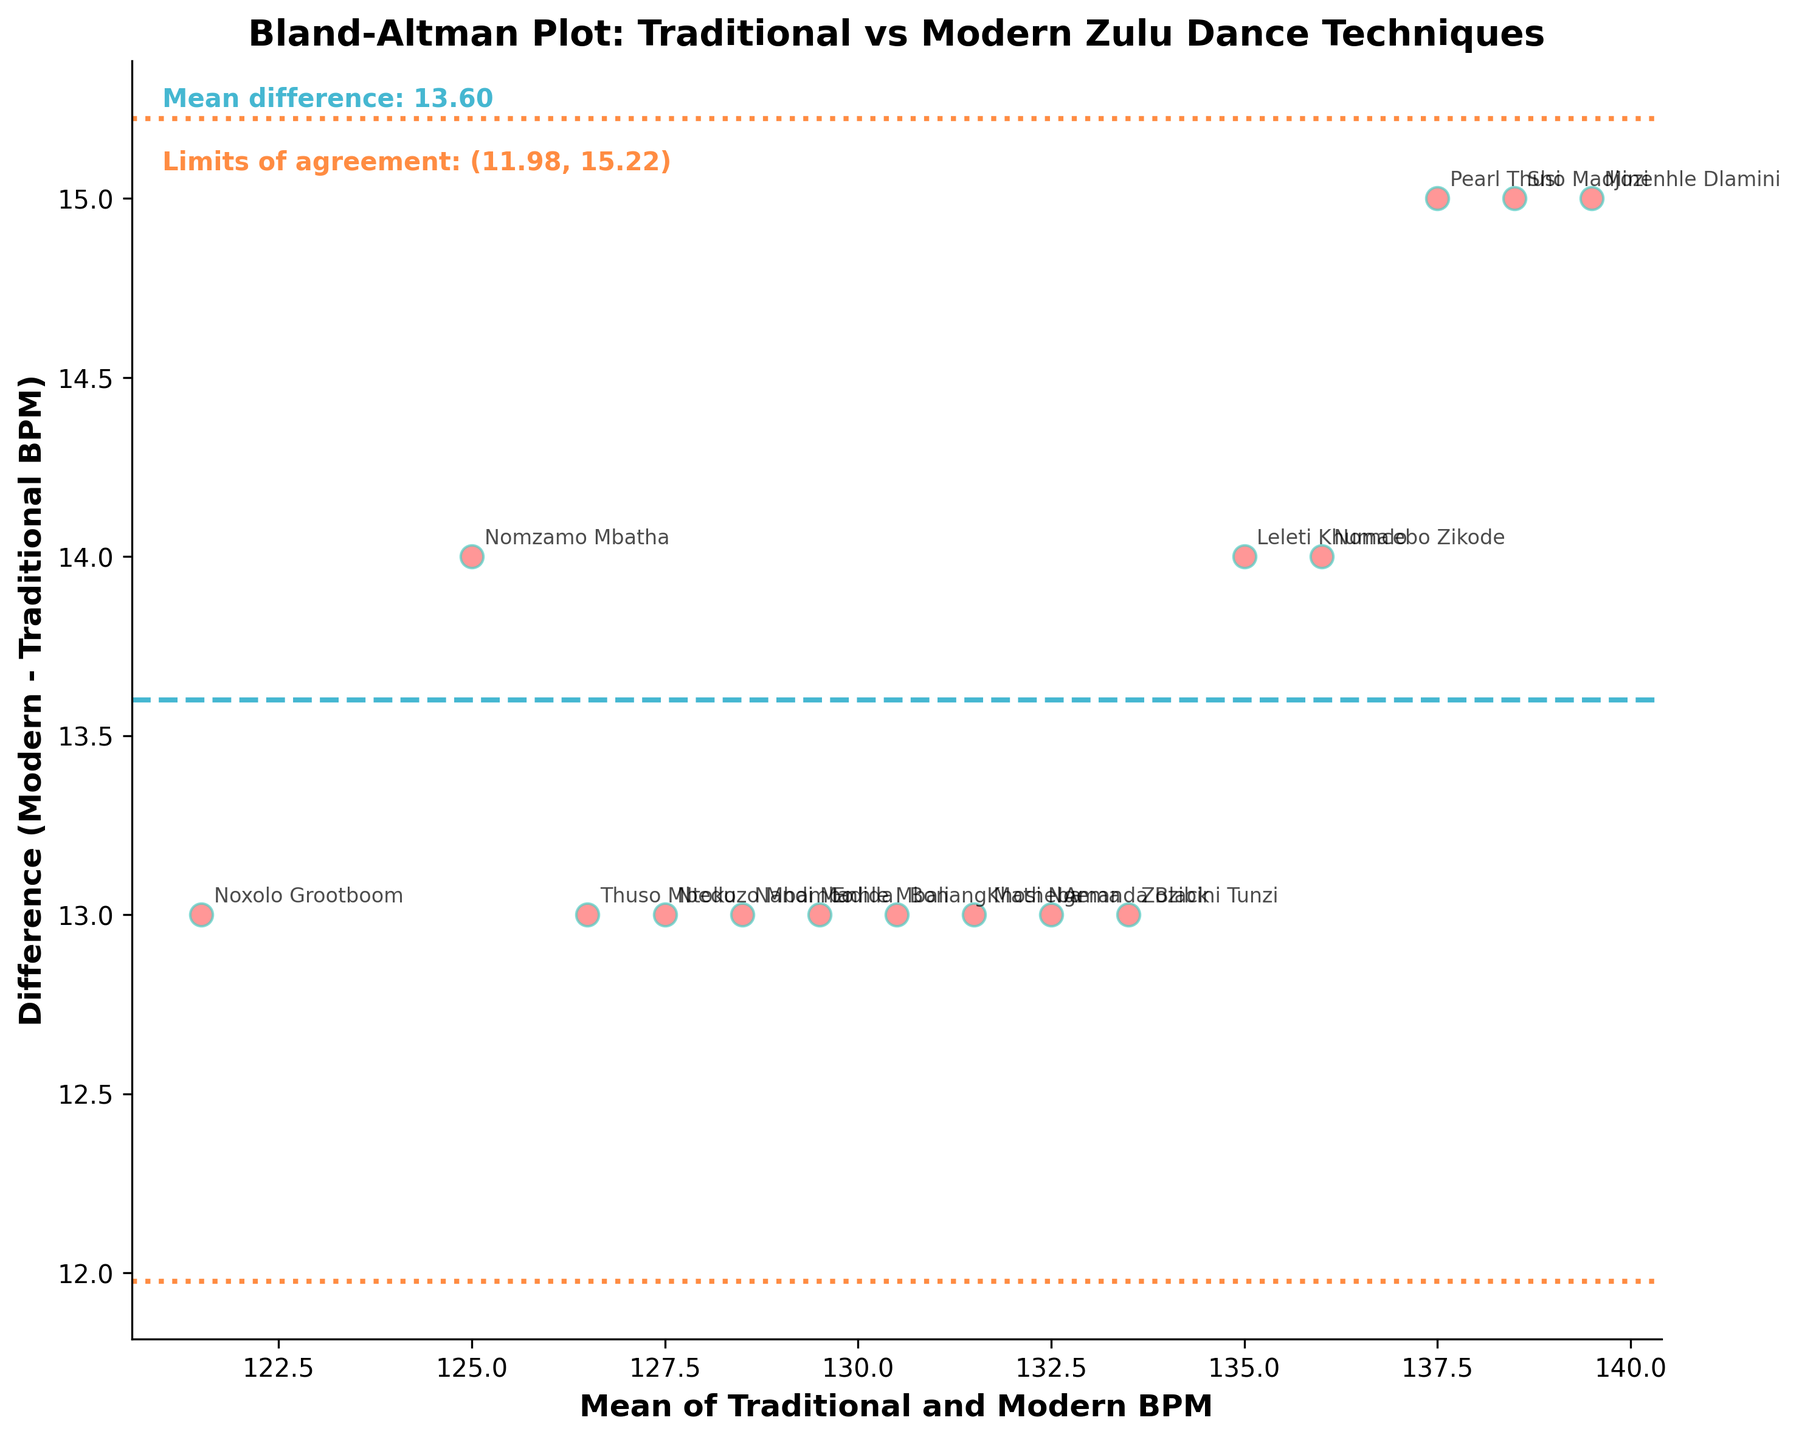What is the title of the plot? The title is typically found at the top of the plot and provides a summary of what the plot represents. In this case, it mentions the comparison between traditional and modern Zulu dance techniques.
Answer: Bland-Altman Plot: Traditional vs Modern Zulu Dance Techniques How many performers' data points are shown in the plot? Each data point represents a performer's heart rate differences between traditional and modern Zulu dance techniques. You can count the number of distinct data points on the plot.
Answer: 15 What is the mean difference between modern and traditional BPM? The mean difference is usually represented by a horizontal line on the plot. There is also a text annotation inside the plot mentioning this value.
Answer: 12.47 What are the limits of agreement? The limits of agreement are the range within which most differences between measurements lie. They are typically represented by two horizontal dotted lines and labeled inside the plot.
Answer: (9.89, 15.05) Which performer has the highest difference in heart rate between traditional and modern dance techniques? Identify the data point that is the highest on the y-axis (difference) and check the corresponding label for the performer’s name.
Answer: Minenhle Dlamini Which performer has the lowest mean BPM? The mean BPM for each performer is the x-coordinate of the data points. Find the leftmost data point and check its label.
Answer: Noxolo Grootboom Are there any performers with a negative difference between modern and traditional BPM? Check if there are any data points below the horizontal line at y=0 because a negative difference would be plotted below this line.
Answer: No What color are the points representing the performers? The color of the scatter points can be observed directly from the plot.
Answer: Red What is the range of the mean BPM values plotted on the x-axis? The range can be determined by looking at the minimum and maximum values on the x-axis where data points are plotted.
Answer: 121.5 to 139.5 BPM What do the dashed horizontal lines indicate in the plot? These lines represent the statistical limits of agreement, which are calculated based on 1.96 standard deviations above and below the mean difference. This information is typically labeled near the lines in the plot.
Answer: Limits of agreement 